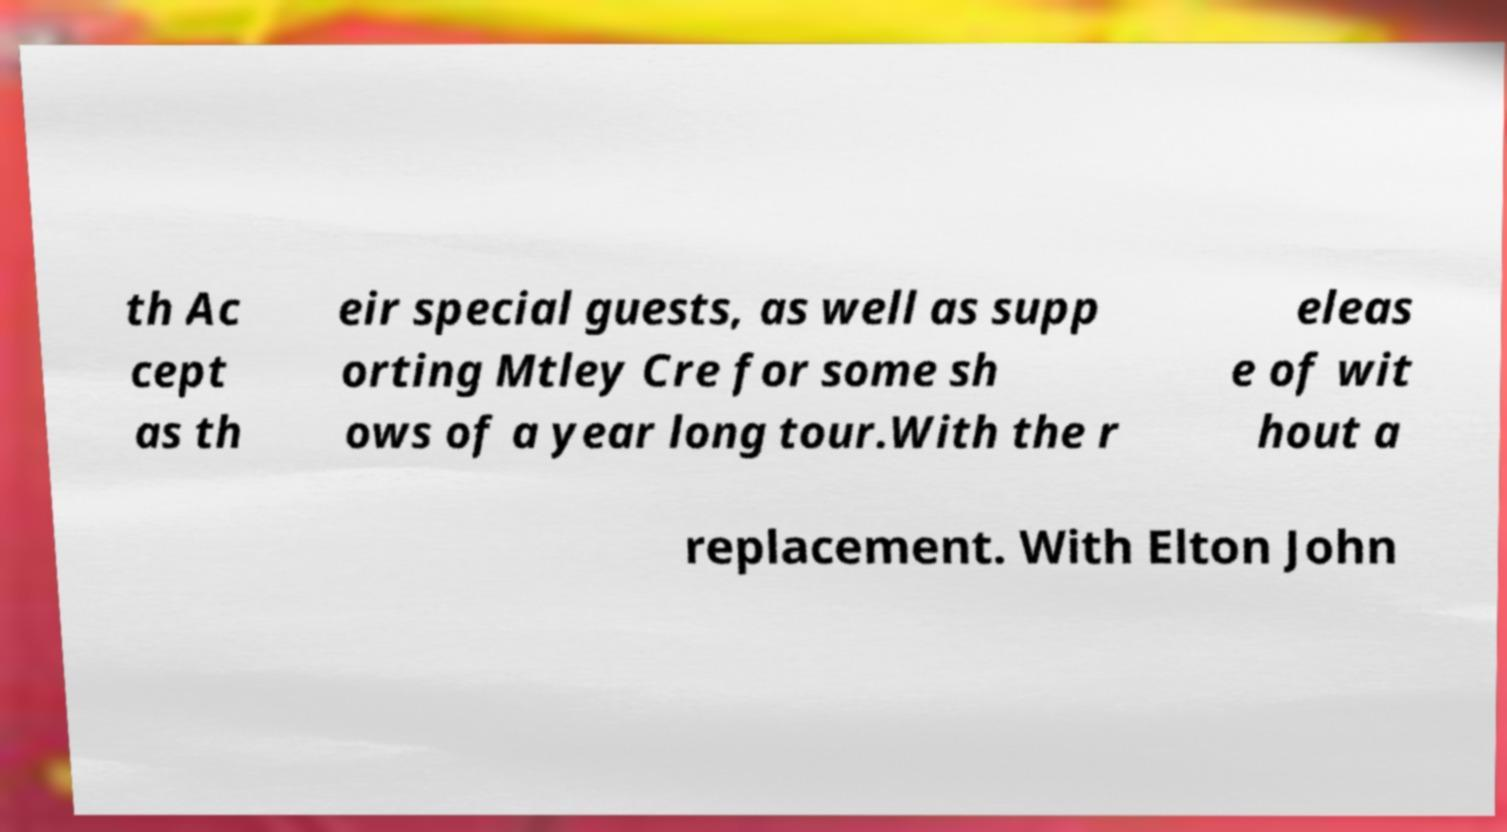For documentation purposes, I need the text within this image transcribed. Could you provide that? th Ac cept as th eir special guests, as well as supp orting Mtley Cre for some sh ows of a year long tour.With the r eleas e of wit hout a replacement. With Elton John 